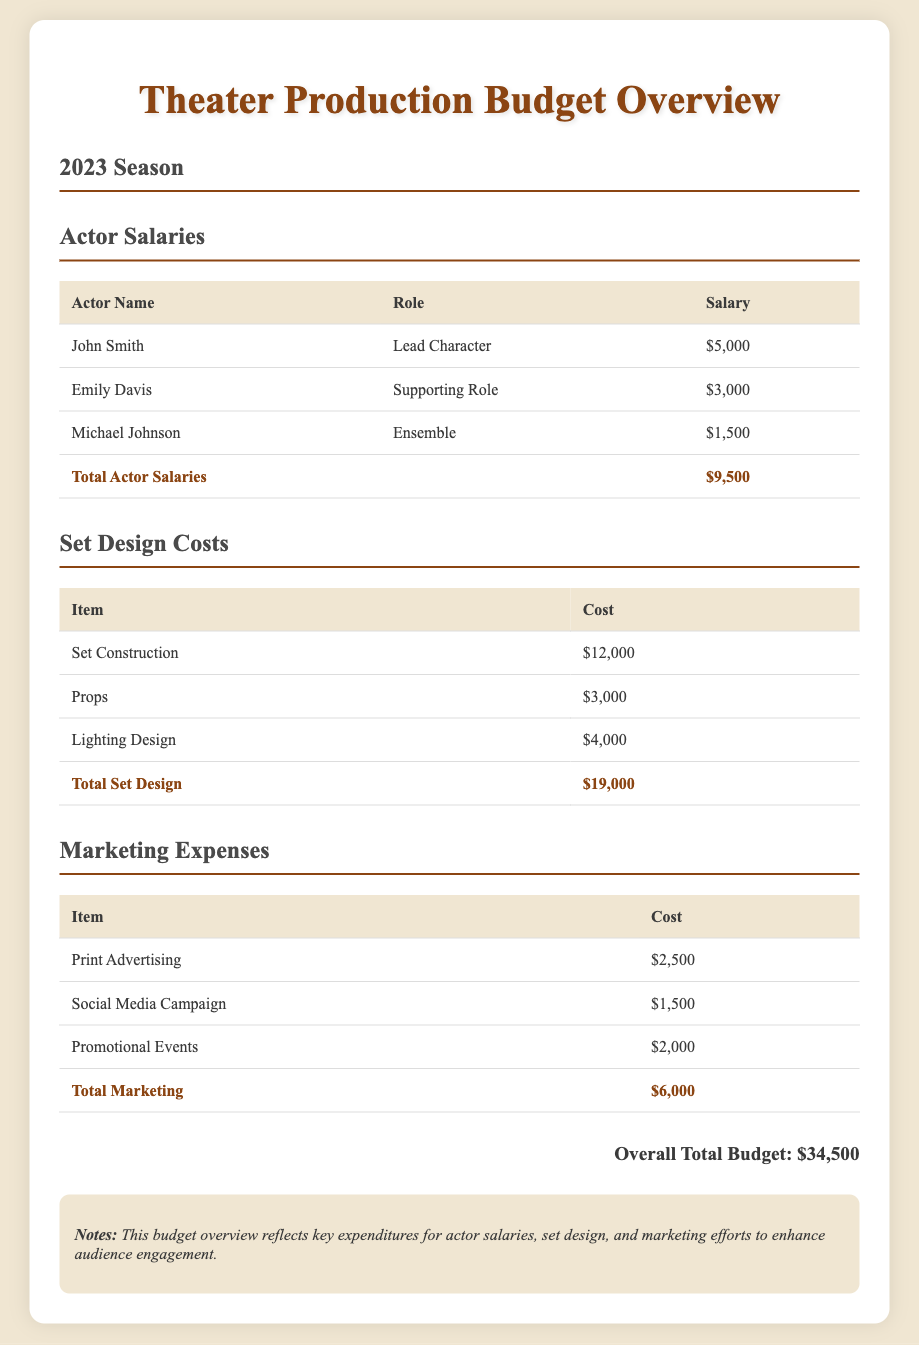What is the total amount allocated for actor salaries? The total actor salaries are listed in the document as $9,500.
Answer: $9,500 How much does set construction cost? The document specifies that set construction costs $12,000.
Answer: $12,000 What is the total marketing expense? The total marketing expenses shown in the document add up to $6,000.
Answer: $6,000 Who is in the lead character role? The document lists John Smith as the lead character.
Answer: John Smith What is the overall total budget for the season? The overall total budget is explicitly stated in the document as $34,500.
Answer: $34,500 How many actors are listed in the salaries table? There are three actors mentioned in the actor salaries table of the document.
Answer: Three What is the cost of lighting design? The lighting design cost specified in the document is $4,000.
Answer: $4,000 Which marketing item has the highest expense? The document indicates that print advertising has the highest expense at $2,500.
Answer: Print Advertising 